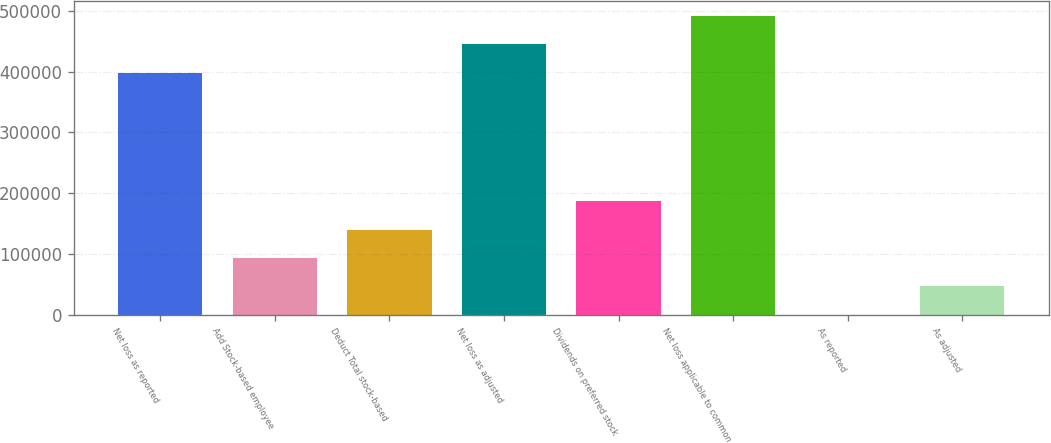Convert chart to OTSL. <chart><loc_0><loc_0><loc_500><loc_500><bar_chart><fcel>Net loss as reported<fcel>Add Stock-based employee<fcel>Deduct Total stock-based<fcel>Net loss as adjusted<fcel>Dividends on preferred stock<fcel>Net loss applicable to common<fcel>As reported<fcel>As adjusted<nl><fcel>398365<fcel>93316.5<fcel>139974<fcel>445022<fcel>186631<fcel>491679<fcel>2.09<fcel>46659.3<nl></chart> 